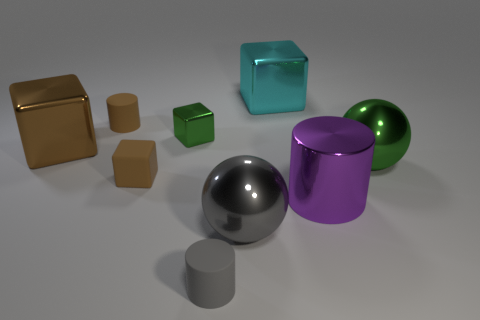Subtract all matte cubes. How many cubes are left? 3 Subtract all purple cylinders. How many brown cubes are left? 2 Subtract all cyan cubes. How many cubes are left? 3 Subtract all cylinders. How many objects are left? 6 Subtract all purple blocks. Subtract all yellow spheres. How many blocks are left? 4 Subtract all cyan cubes. Subtract all brown matte cylinders. How many objects are left? 7 Add 8 tiny green blocks. How many tiny green blocks are left? 9 Add 7 big spheres. How many big spheres exist? 9 Subtract 1 green spheres. How many objects are left? 8 